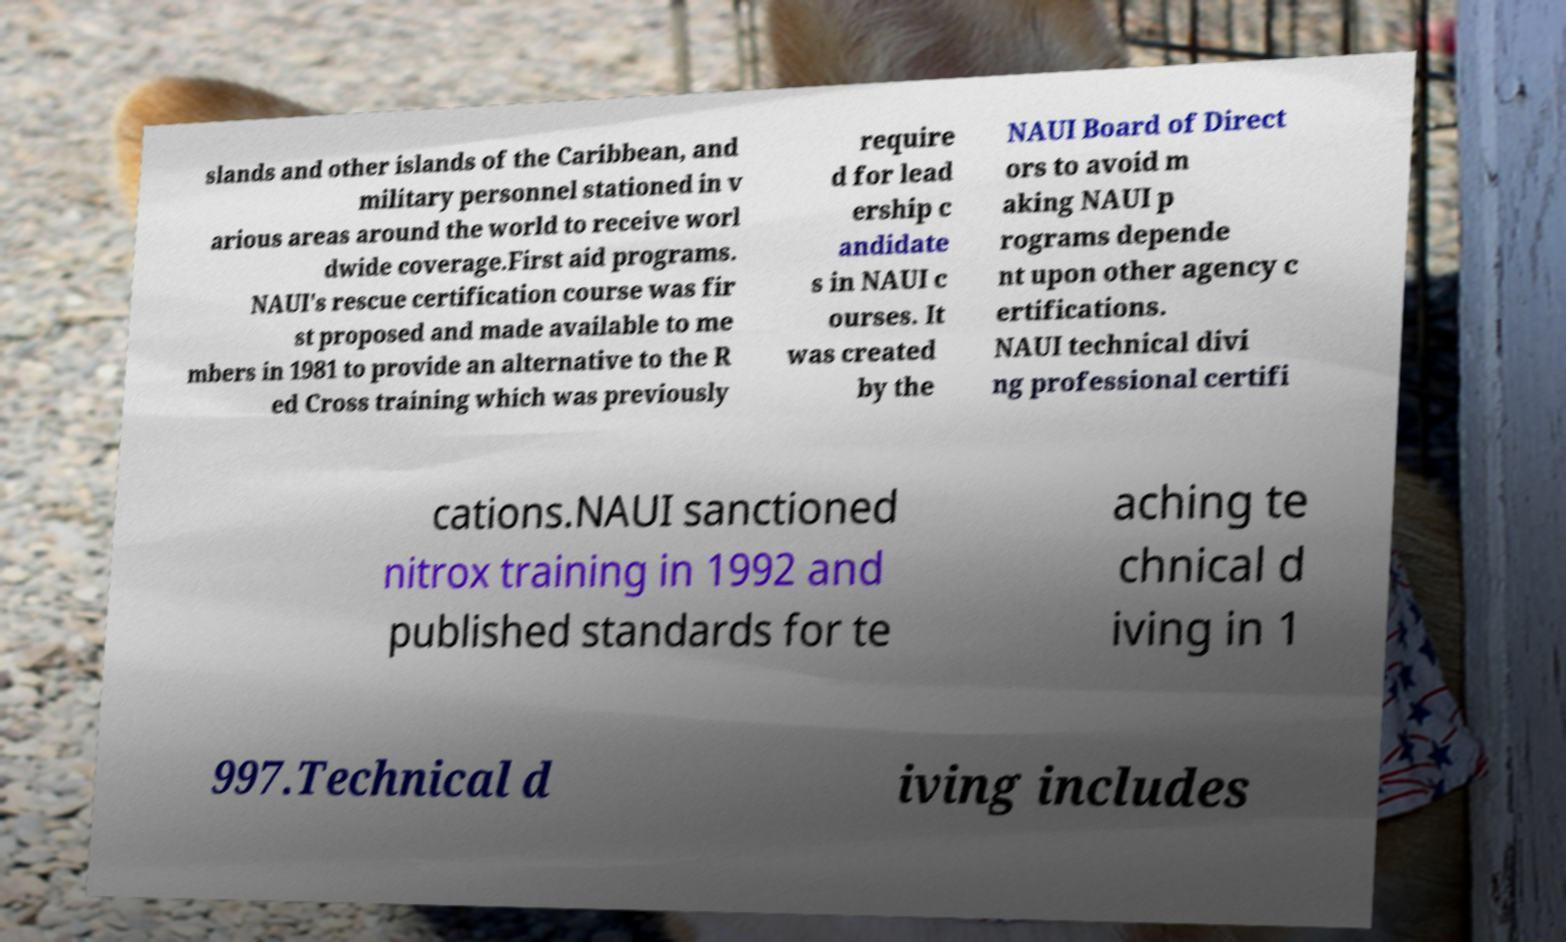What messages or text are displayed in this image? I need them in a readable, typed format. slands and other islands of the Caribbean, and military personnel stationed in v arious areas around the world to receive worl dwide coverage.First aid programs. NAUI's rescue certification course was fir st proposed and made available to me mbers in 1981 to provide an alternative to the R ed Cross training which was previously require d for lead ership c andidate s in NAUI c ourses. It was created by the NAUI Board of Direct ors to avoid m aking NAUI p rograms depende nt upon other agency c ertifications. NAUI technical divi ng professional certifi cations.NAUI sanctioned nitrox training in 1992 and published standards for te aching te chnical d iving in 1 997.Technical d iving includes 